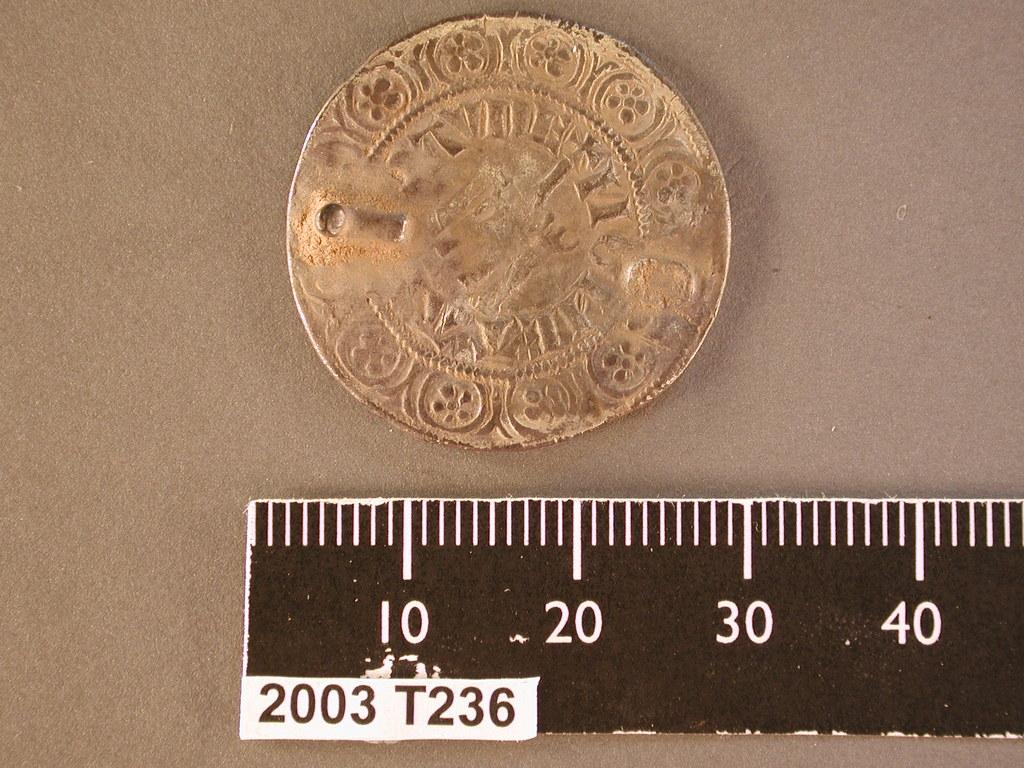Provide a one-sentence caption for the provided image. A golden coin next to ruler with the number 2003 printed on it. 